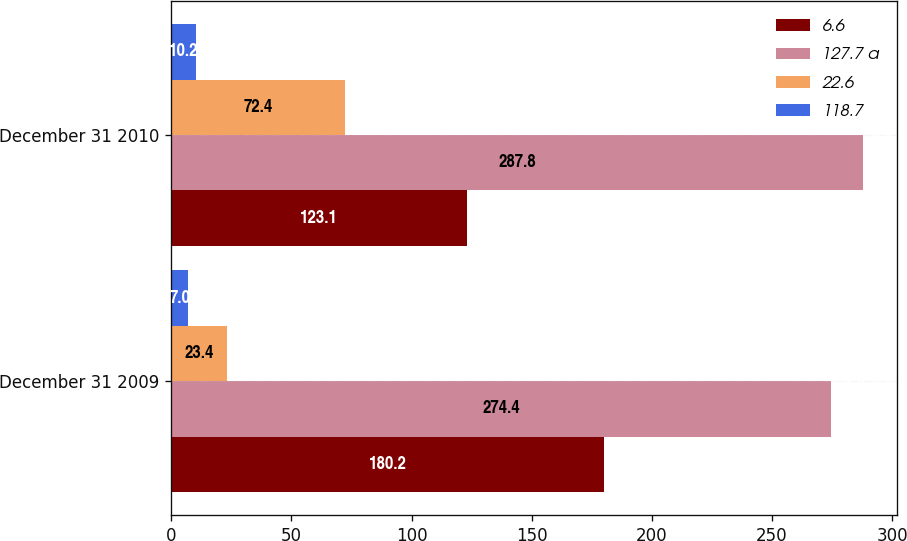<chart> <loc_0><loc_0><loc_500><loc_500><stacked_bar_chart><ecel><fcel>December 31 2009<fcel>December 31 2010<nl><fcel>6.6<fcel>180.2<fcel>123.1<nl><fcel>127.7 a<fcel>274.4<fcel>287.8<nl><fcel>22.6<fcel>23.4<fcel>72.4<nl><fcel>118.7<fcel>7<fcel>10.2<nl></chart> 